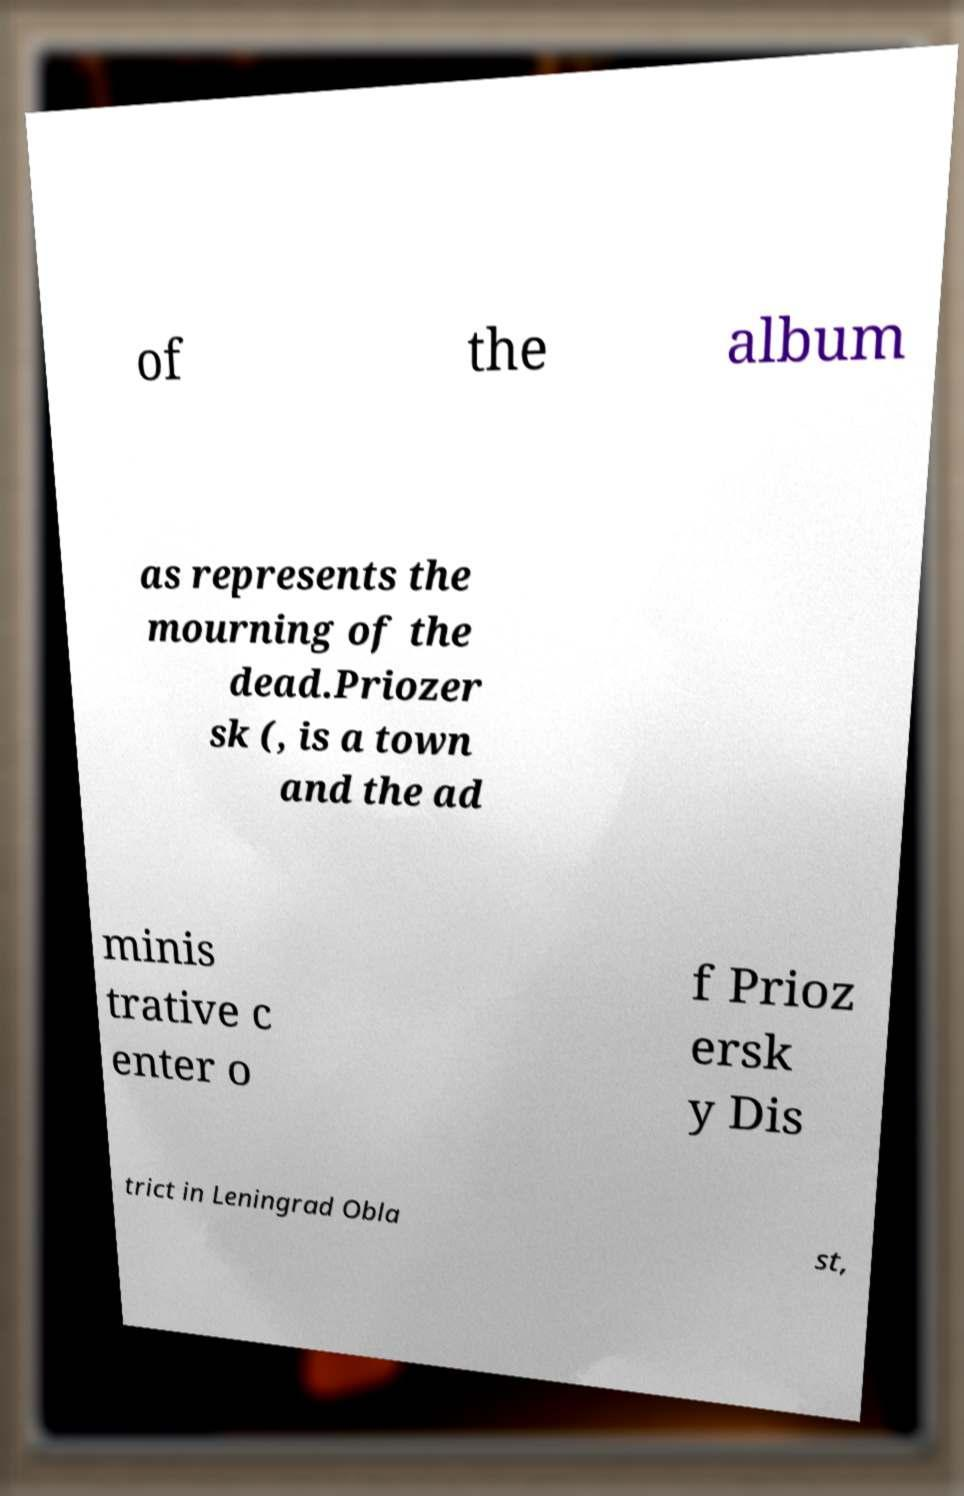Could you assist in decoding the text presented in this image and type it out clearly? of the album as represents the mourning of the dead.Priozer sk (, is a town and the ad minis trative c enter o f Prioz ersk y Dis trict in Leningrad Obla st, 